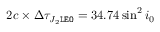Convert formula to latex. <formula><loc_0><loc_0><loc_500><loc_500>2 c \times \Delta \tau _ { J _ { 2 } \tt L E O } = 3 4 . 7 4 \sin ^ { 2 } i _ { 0 }</formula> 